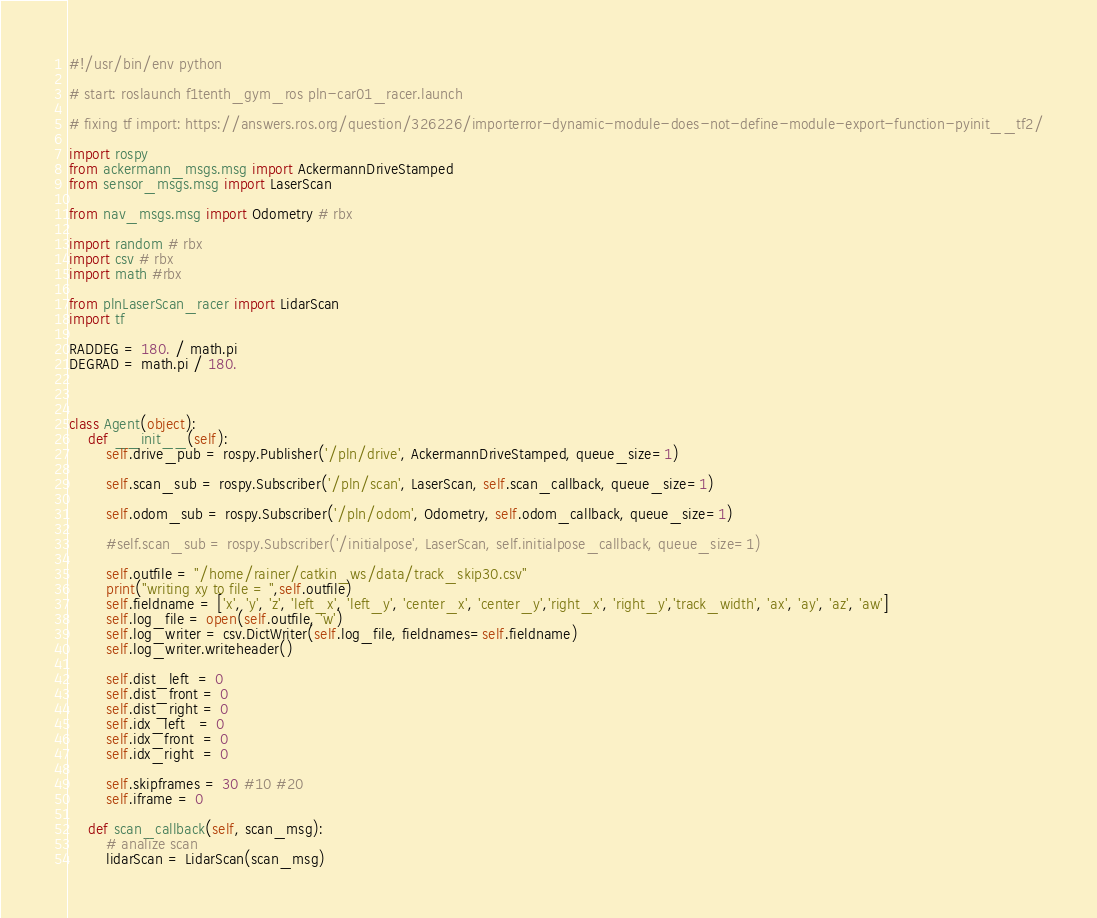Convert code to text. <code><loc_0><loc_0><loc_500><loc_500><_Python_>#!/usr/bin/env python

# start: roslaunch f1tenth_gym_ros pln-car01_racer.launch

# fixing tf import: https://answers.ros.org/question/326226/importerror-dynamic-module-does-not-define-module-export-function-pyinit__tf2/

import rospy
from ackermann_msgs.msg import AckermannDriveStamped
from sensor_msgs.msg import LaserScan

from nav_msgs.msg import Odometry # rbx

import random # rbx
import csv # rbx
import math #rbx

from plnLaserScan_racer import LidarScan
import tf

RADDEG = 180. / math.pi 
DEGRAD = math.pi / 180.



class Agent(object):
    def __init__(self):
        self.drive_pub = rospy.Publisher('/pln/drive', AckermannDriveStamped, queue_size=1)

        self.scan_sub = rospy.Subscriber('/pln/scan', LaserScan, self.scan_callback, queue_size=1)

        self.odom_sub = rospy.Subscriber('/pln/odom', Odometry, self.odom_callback, queue_size=1)

        #self.scan_sub = rospy.Subscriber('/initialpose', LaserScan, self.initialpose_callback, queue_size=1)

        self.outfile = "/home/rainer/catkin_ws/data/track_skip30.csv"
        print("writing xy to file = ",self.outfile)
        self.fieldname = ['x', 'y', 'z', 'left_x', 'left_y', 'center_x', 'center_y','right_x', 'right_y','track_width', 'ax', 'ay', 'az', 'aw']
        self.log_file = open(self.outfile, 'w')
        self.log_writer = csv.DictWriter(self.log_file, fieldnames=self.fieldname)
        self.log_writer.writeheader()

        self.dist_left  = 0
        self.dist_front = 0
        self.dist_right = 0
        self.idx_left   = 0
        self.idx_front  = 0
        self.idx_right  = 0

        self.skipframes = 30 #10 #20
        self.iframe = 0

    def scan_callback(self, scan_msg):
        # analize scan
        lidarScan = LidarScan(scan_msg)</code> 